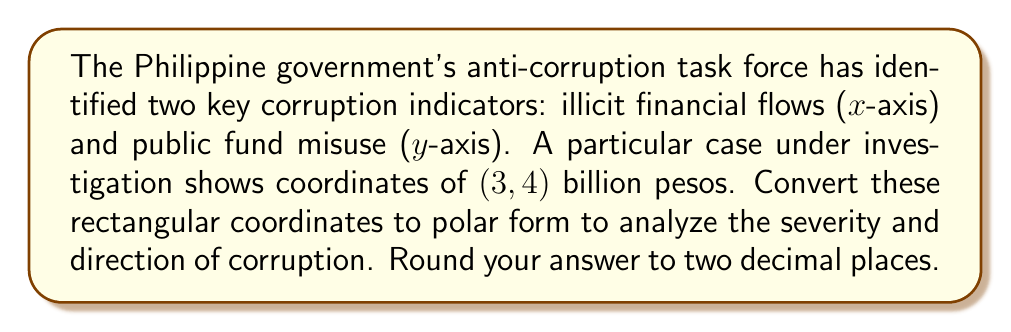Teach me how to tackle this problem. To convert rectangular coordinates $(x, y)$ to polar coordinates $(r, \theta)$, we use the following formulas:

1. $r = \sqrt{x^2 + y^2}$
2. $\theta = \tan^{-1}(\frac{y}{x})$

Given: $(x, y) = (3, 4)$

Step 1: Calculate $r$
$$r = \sqrt{3^2 + 4^2} = \sqrt{9 + 16} = \sqrt{25} = 5$$

Step 2: Calculate $\theta$
$$\theta = \tan^{-1}(\frac{4}{3}) \approx 0.9273 \text{ radians}$$

To convert radians to degrees, multiply by $\frac{180}{\pi}$:
$$0.9273 \times \frac{180}{\pi} \approx 53.13°$$

Therefore, the polar coordinates are $(5, 53.13°)$.

Interpretation:
- The magnitude (r) of 5 billion pesos represents the overall severity of corruption.
- The angle (θ) of 53.13° indicates the relative contribution of each factor, with 0° representing pure illicit financial flows and 90° representing pure public fund misuse.
Answer: $(5, 53.13°)$ 